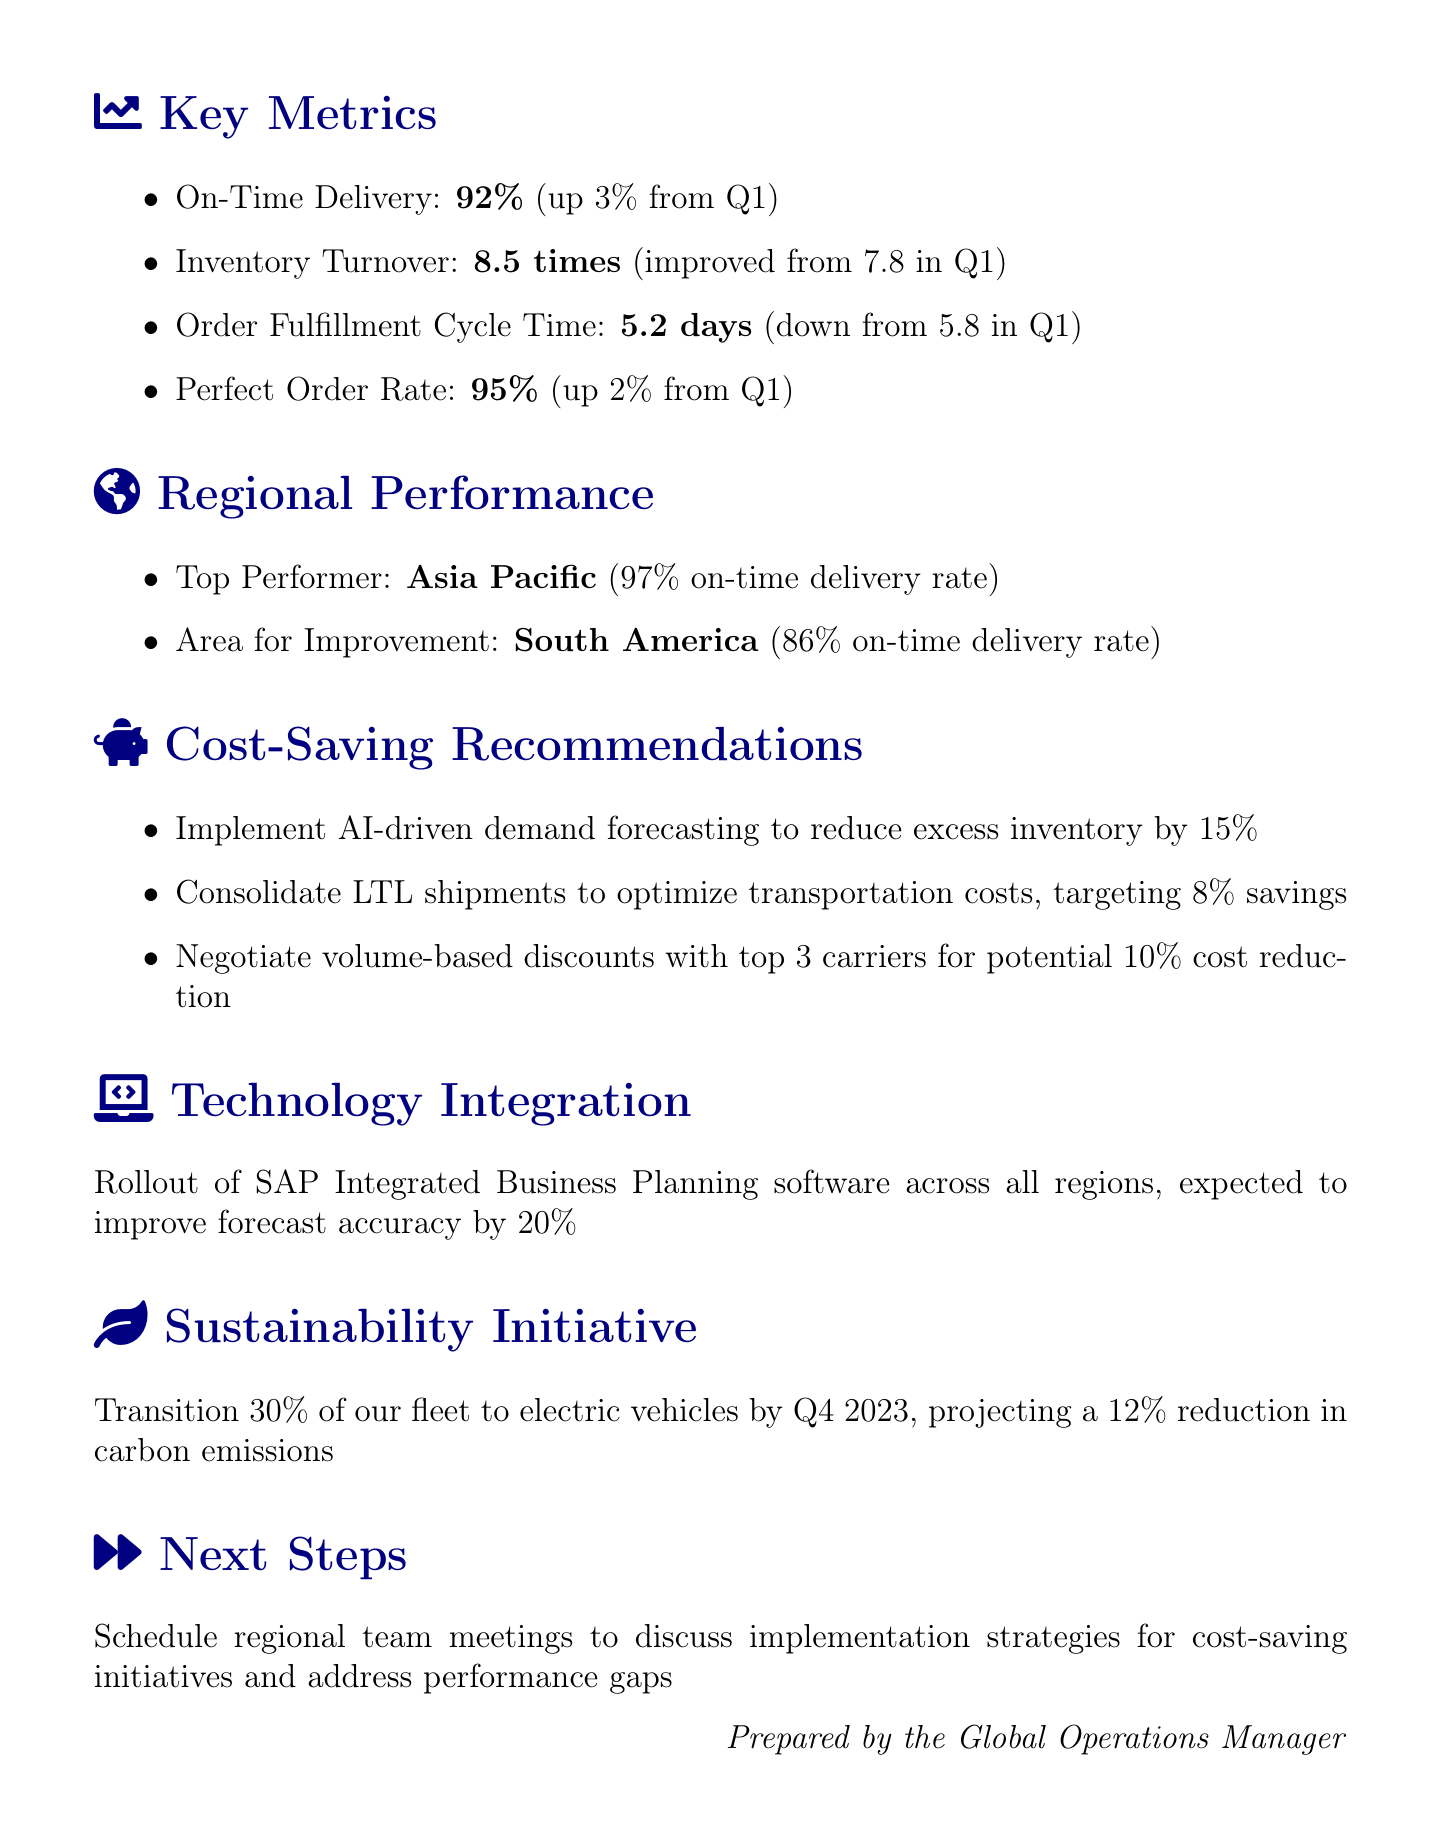What is the on-time delivery rate for Q2 2023? The on-time delivery rate for Q2 2023 is found in the key metrics section, which states it is 92%.
Answer: 92% What was the inventory turnover in Q1 2023? The document indicates the inventory turnover improved from 7.8 in Q1 to 8.5 in Q2, so it was 7.8 in Q1.
Answer: 7.8 Which region had the highest on-time delivery rate? The top performer is listed in the regional performance section, which identifies Asia Pacific with a 97% on-time delivery rate.
Answer: Asia Pacific What is one of the recommendations for cost savings? The cost-saving recommendations section provides several suggestions, one being to implement AI-driven demand forecasting to reduce excess inventory.
Answer: Implement AI-driven demand forecasting What is the expected improvement in forecast accuracy from technology integration? The document states that the rollout of SAP Integrated Business Planning software is expected to improve forecast accuracy by 20%.
Answer: 20% What percentage of the fleet is projected to transition to electric vehicles? In the sustainability initiative section, it indicates that 30% of the fleet will transition to electric vehicles by Q4 2023.
Answer: 30% What are the next steps mentioned in the report? The next steps section specifies scheduling regional team meetings to discuss implementation strategies for cost-saving initiatives.
Answer: Schedule regional team meetings What is the perfect order rate for Q2 2023? The key metrics section lists the perfect order rate as 95% for Q2 2023, which has increased by 2% from Q1.
Answer: 95% 